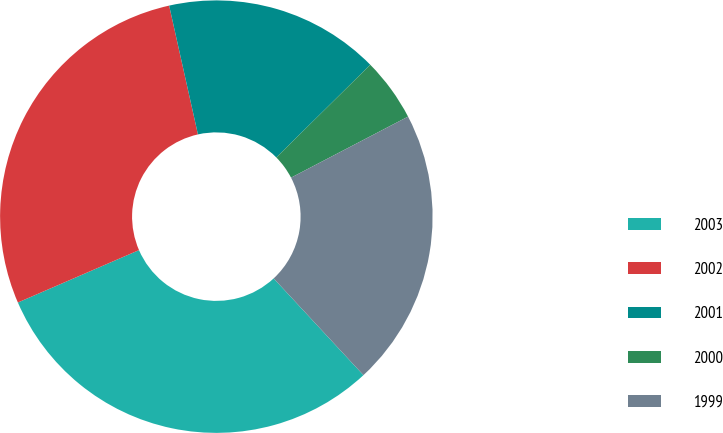Convert chart. <chart><loc_0><loc_0><loc_500><loc_500><pie_chart><fcel>2003<fcel>2002<fcel>2001<fcel>2000<fcel>1999<nl><fcel>30.41%<fcel>28.0%<fcel>16.11%<fcel>4.74%<fcel>20.75%<nl></chart> 